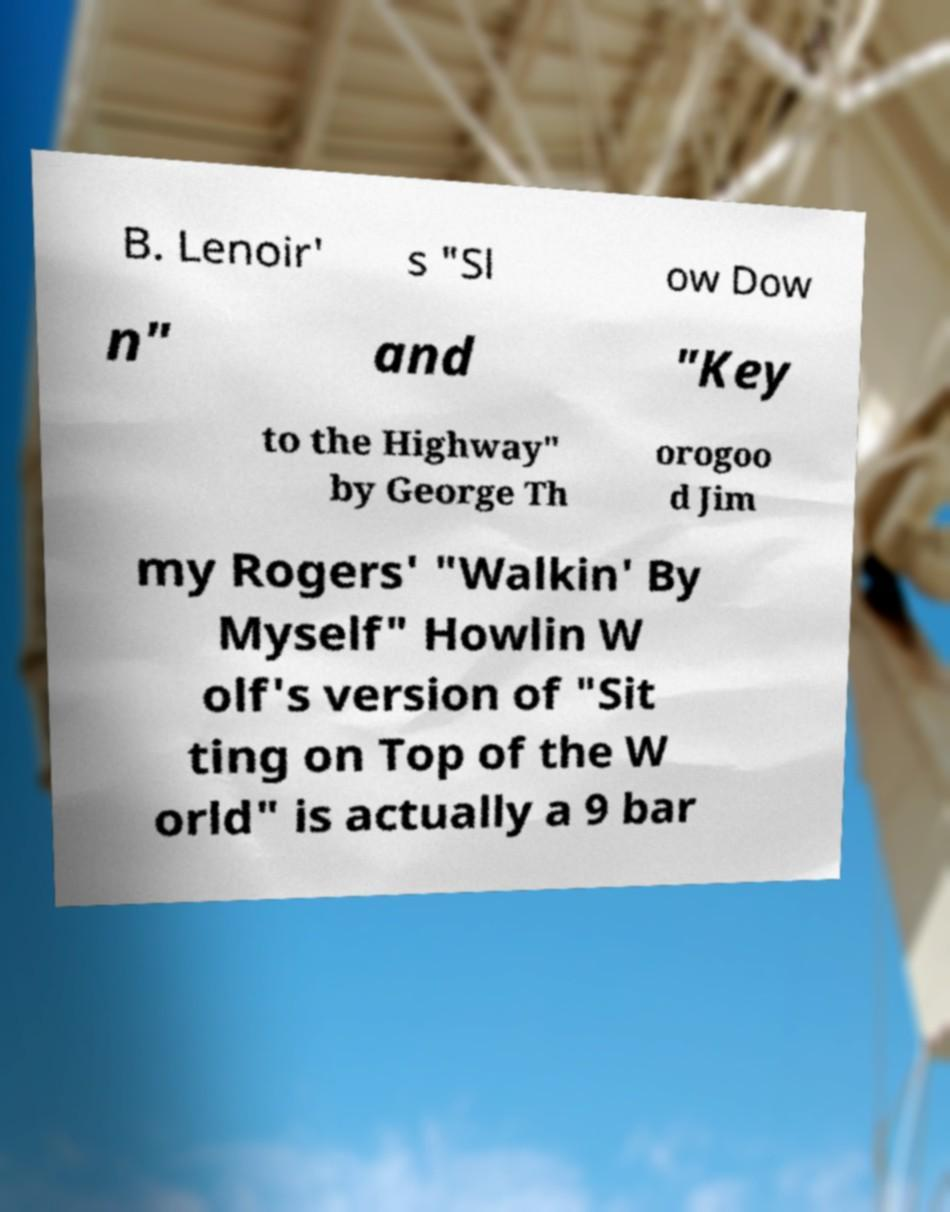Could you assist in decoding the text presented in this image and type it out clearly? B. Lenoir' s "Sl ow Dow n" and "Key to the Highway" by George Th orogoo d Jim my Rogers' "Walkin' By Myself" Howlin W olf's version of "Sit ting on Top of the W orld" is actually a 9 bar 